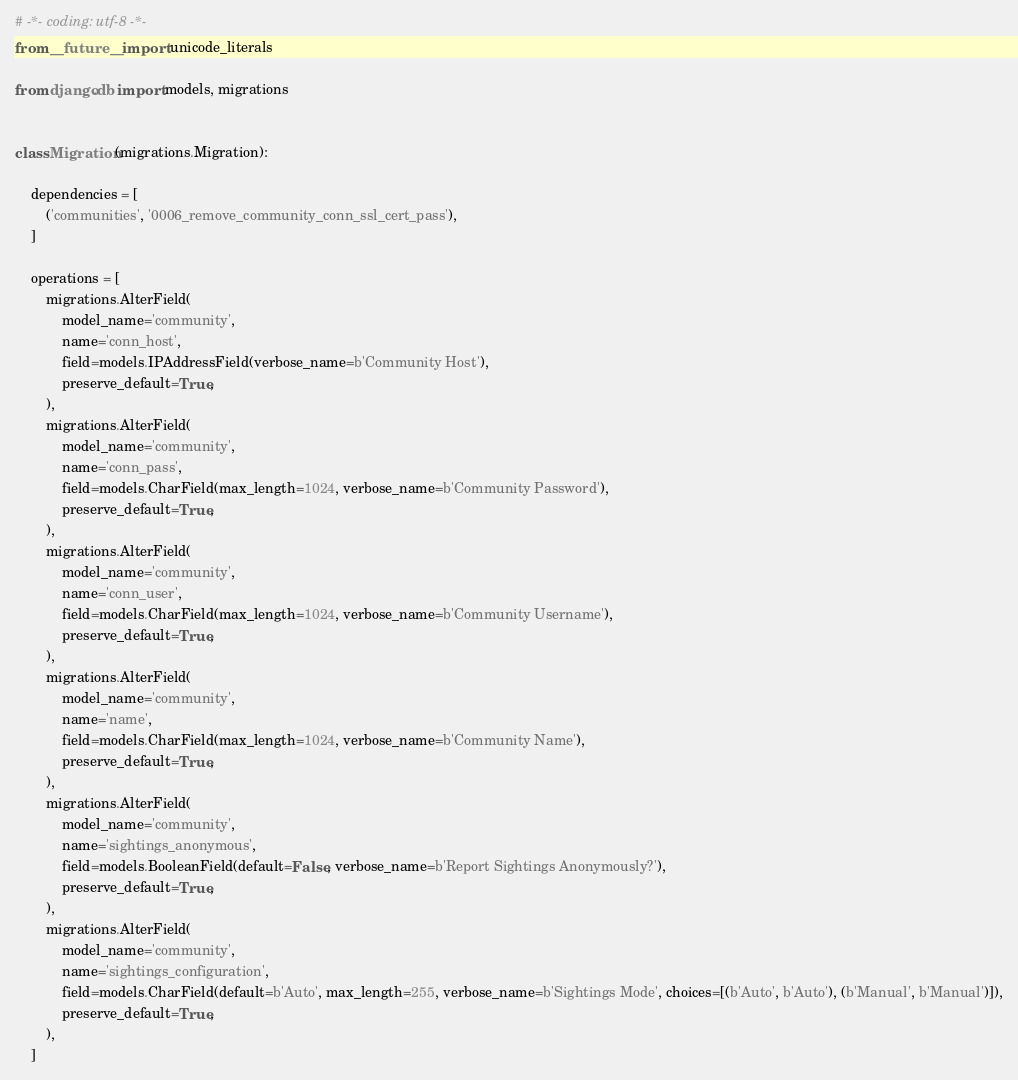<code> <loc_0><loc_0><loc_500><loc_500><_Python_># -*- coding: utf-8 -*-
from __future__ import unicode_literals

from django.db import models, migrations


class Migration(migrations.Migration):

    dependencies = [
        ('communities', '0006_remove_community_conn_ssl_cert_pass'),
    ]

    operations = [
        migrations.AlterField(
            model_name='community',
            name='conn_host',
            field=models.IPAddressField(verbose_name=b'Community Host'),
            preserve_default=True,
        ),
        migrations.AlterField(
            model_name='community',
            name='conn_pass',
            field=models.CharField(max_length=1024, verbose_name=b'Community Password'),
            preserve_default=True,
        ),
        migrations.AlterField(
            model_name='community',
            name='conn_user',
            field=models.CharField(max_length=1024, verbose_name=b'Community Username'),
            preserve_default=True,
        ),
        migrations.AlterField(
            model_name='community',
            name='name',
            field=models.CharField(max_length=1024, verbose_name=b'Community Name'),
            preserve_default=True,
        ),
        migrations.AlterField(
            model_name='community',
            name='sightings_anonymous',
            field=models.BooleanField(default=False, verbose_name=b'Report Sightings Anonymously?'),
            preserve_default=True,
        ),
        migrations.AlterField(
            model_name='community',
            name='sightings_configuration',
            field=models.CharField(default=b'Auto', max_length=255, verbose_name=b'Sightings Mode', choices=[(b'Auto', b'Auto'), (b'Manual', b'Manual')]),
            preserve_default=True,
        ),
    ]
</code> 